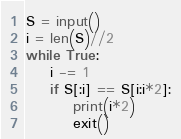<code> <loc_0><loc_0><loc_500><loc_500><_Python_>S = input()
i = len(S)//2
while True:
    i -= 1
    if S[:i] == S[i:i*2]:
        print(i*2)
        exit()</code> 